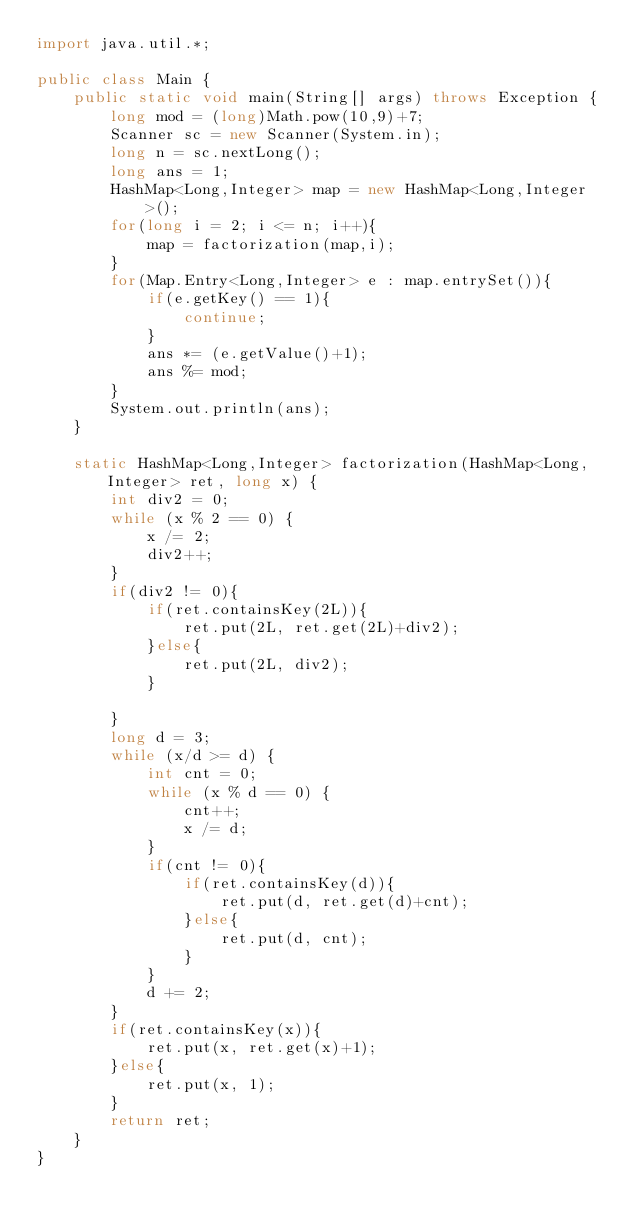Convert code to text. <code><loc_0><loc_0><loc_500><loc_500><_Java_>import java.util.*;

public class Main {
    public static void main(String[] args) throws Exception {
        long mod = (long)Math.pow(10,9)+7;
        Scanner sc = new Scanner(System.in);
        long n = sc.nextLong();
        long ans = 1;
        HashMap<Long,Integer> map = new HashMap<Long,Integer>();
        for(long i = 2; i <= n; i++){
            map = factorization(map,i);
        }
        for(Map.Entry<Long,Integer> e : map.entrySet()){
            if(e.getKey() == 1){
                continue;
            }
            ans *= (e.getValue()+1);
            ans %= mod;
        }
        System.out.println(ans);
    }
    
    static HashMap<Long,Integer> factorization(HashMap<Long,Integer> ret, long x) {
        int div2 = 0;
        while (x % 2 == 0) {
            x /= 2;
            div2++;
        }
        if(div2 != 0){
            if(ret.containsKey(2L)){
                ret.put(2L, ret.get(2L)+div2);
            }else{
                ret.put(2L, div2);
            }
            
        }
        long d = 3;
        while (x/d >= d) {
            int cnt = 0;
            while (x % d == 0) {
                cnt++;
                x /= d;
            }
            if(cnt != 0){
                if(ret.containsKey(d)){
                    ret.put(d, ret.get(d)+cnt);
                }else{
                    ret.put(d, cnt);
                }   
            }
            d += 2;
        }
        if(ret.containsKey(x)){
            ret.put(x, ret.get(x)+1);
        }else{
            ret.put(x, 1);
        }
        return ret;
    }
}

</code> 